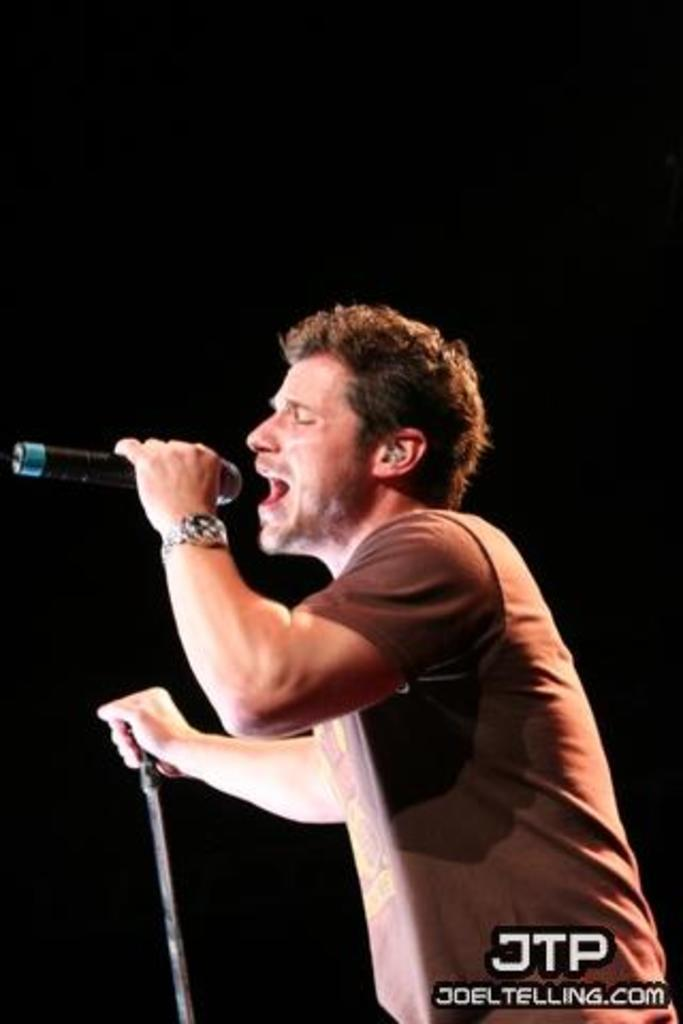What is the person in the image doing? The person is standing in the image and holding a microphone in one hand. What else is the person holding in the image? The person is holding another object in the other hand. What can be observed about the background of the image? The background of the image is dark. What type of fruit is the person holding in the image? There is no fruit present in the image; the person is holding a microphone and another object. 